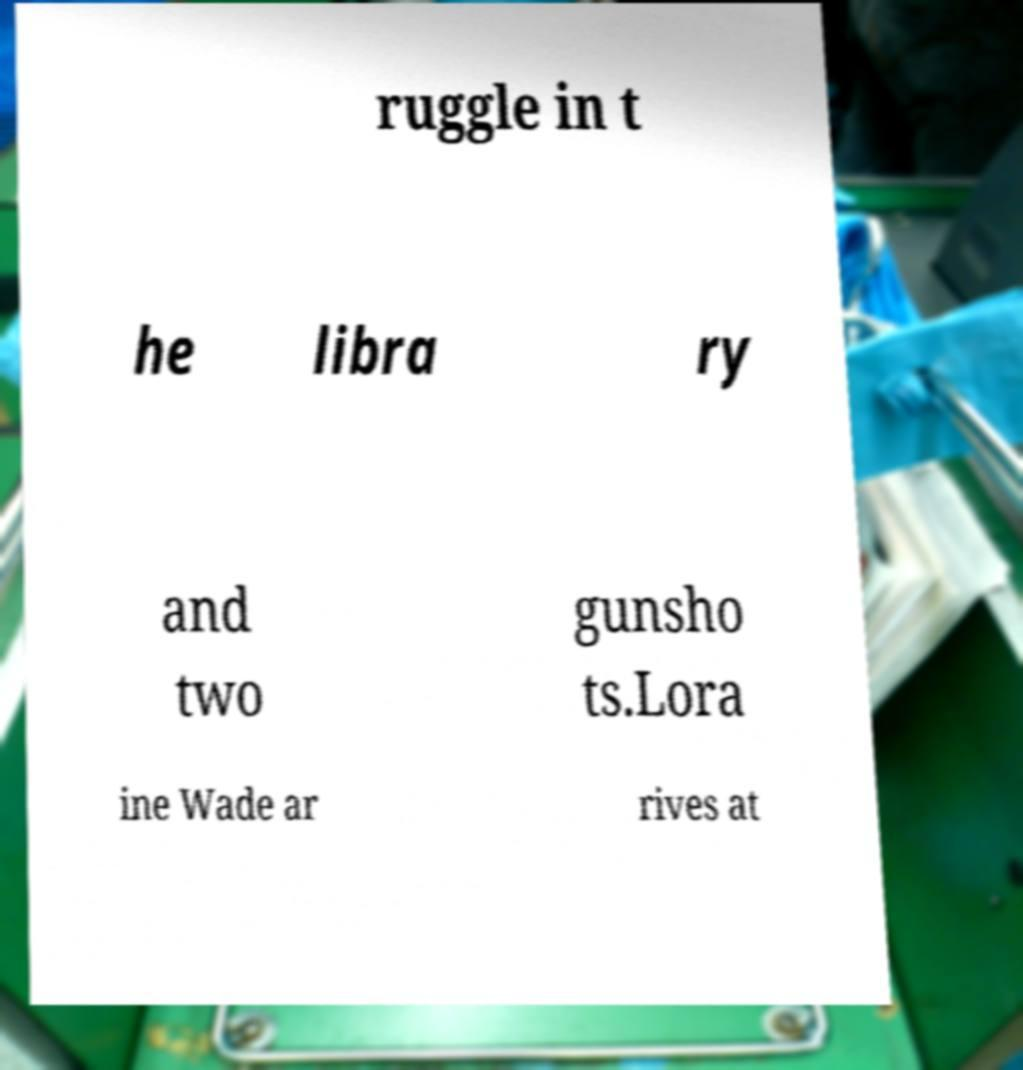There's text embedded in this image that I need extracted. Can you transcribe it verbatim? ruggle in t he libra ry and two gunsho ts.Lora ine Wade ar rives at 